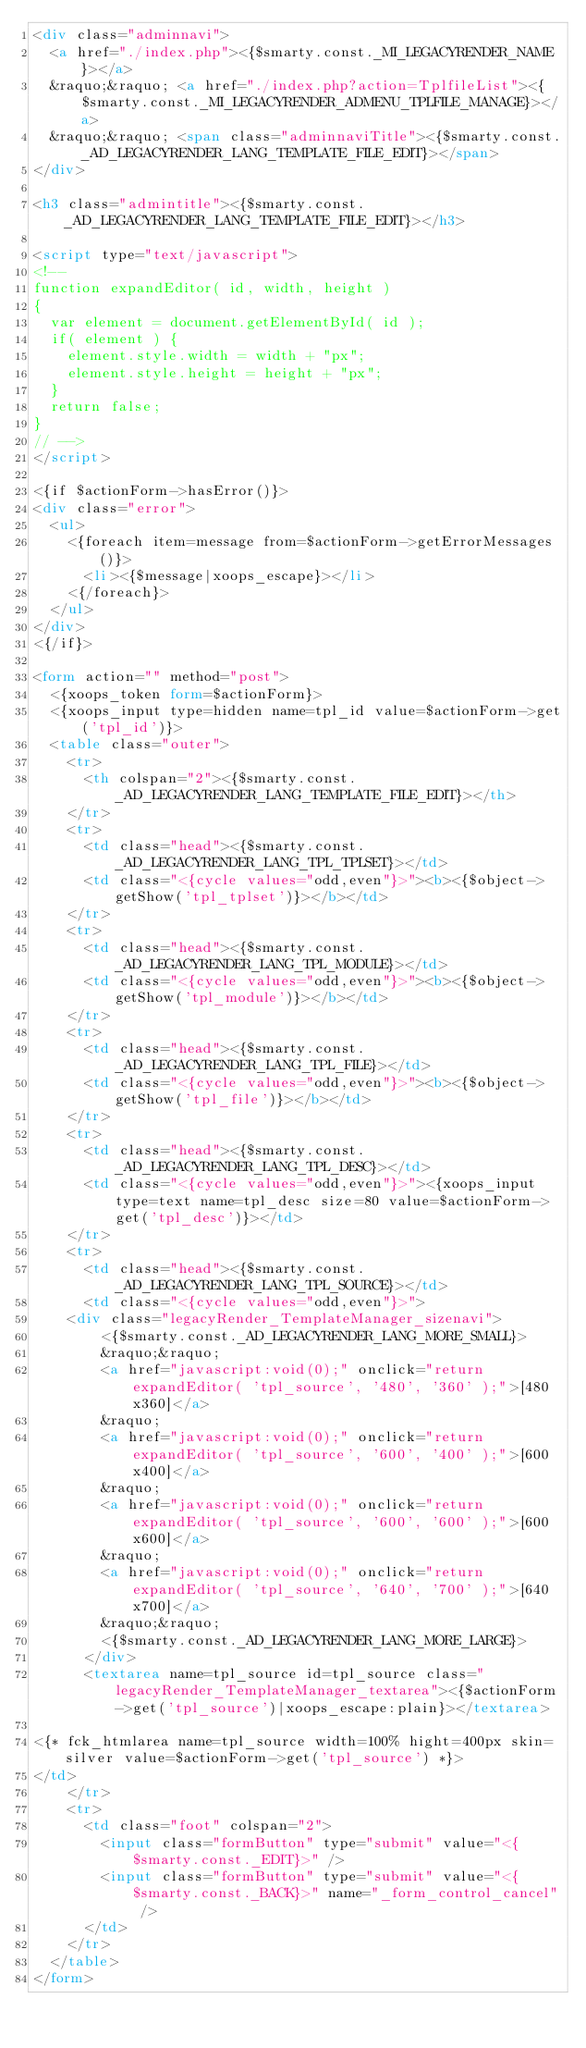Convert code to text. <code><loc_0><loc_0><loc_500><loc_500><_HTML_><div class="adminnavi">
  <a href="./index.php"><{$smarty.const._MI_LEGACYRENDER_NAME}></a>
  &raquo;&raquo; <a href="./index.php?action=TplfileList"><{$smarty.const._MI_LEGACYRENDER_ADMENU_TPLFILE_MANAGE}></a>
  &raquo;&raquo; <span class="adminnaviTitle"><{$smarty.const._AD_LEGACYRENDER_LANG_TEMPLATE_FILE_EDIT}></span>
</div>

<h3 class="admintitle"><{$smarty.const._AD_LEGACYRENDER_LANG_TEMPLATE_FILE_EDIT}></h3>

<script type="text/javascript">
<!--
function expandEditor( id, width, height )
{
  var element = document.getElementById( id );
  if( element ) {
    element.style.width = width + "px";
    element.style.height = height + "px";
  }
  return false;
}
// -->
</script>

<{if $actionForm->hasError()}>
<div class="error">
  <ul>
    <{foreach item=message from=$actionForm->getErrorMessages()}>
      <li><{$message|xoops_escape}></li>
    <{/foreach}>
  </ul>
</div>
<{/if}>

<form action="" method="post">
  <{xoops_token form=$actionForm}>
  <{xoops_input type=hidden name=tpl_id value=$actionForm->get('tpl_id')}>
  <table class="outer">
    <tr>
      <th colspan="2"><{$smarty.const._AD_LEGACYRENDER_LANG_TEMPLATE_FILE_EDIT}></th>
    </tr>
    <tr>
      <td class="head"><{$smarty.const._AD_LEGACYRENDER_LANG_TPL_TPLSET}></td>
      <td class="<{cycle values="odd,even"}>"><b><{$object->getShow('tpl_tplset')}></b></td>
    </tr>
    <tr>
      <td class="head"><{$smarty.const._AD_LEGACYRENDER_LANG_TPL_MODULE}></td>
      <td class="<{cycle values="odd,even"}>"><b><{$object->getShow('tpl_module')}></b></td>
    </tr>
    <tr>
      <td class="head"><{$smarty.const._AD_LEGACYRENDER_LANG_TPL_FILE}></td>
      <td class="<{cycle values="odd,even"}>"><b><{$object->getShow('tpl_file')}></b></td>
    </tr>
    <tr>
      <td class="head"><{$smarty.const._AD_LEGACYRENDER_LANG_TPL_DESC}></td>
      <td class="<{cycle values="odd,even"}>"><{xoops_input type=text name=tpl_desc size=80 value=$actionForm->get('tpl_desc')}></td>
    </tr>
    <tr>
      <td class="head"><{$smarty.const._AD_LEGACYRENDER_LANG_TPL_SOURCE}></td>
      <td class="<{cycle values="odd,even"}>">
    <div class="legacyRender_TemplateManager_sizenavi">
        <{$smarty.const._AD_LEGACYRENDER_LANG_MORE_SMALL}>
        &raquo;&raquo;
        <a href="javascript:void(0);" onclick="return expandEditor( 'tpl_source', '480', '360' );">[480x360]</a>
        &raquo;
        <a href="javascript:void(0);" onclick="return expandEditor( 'tpl_source', '600', '400' );">[600x400]</a>
        &raquo;
        <a href="javascript:void(0);" onclick="return expandEditor( 'tpl_source', '600', '600' );">[600x600]</a>
        &raquo;
        <a href="javascript:void(0);" onclick="return expandEditor( 'tpl_source', '640', '700' );">[640x700]</a>
        &raquo;&raquo;
        <{$smarty.const._AD_LEGACYRENDER_LANG_MORE_LARGE}>
      </div>
      <textarea name=tpl_source id=tpl_source class="legacyRender_TemplateManager_textarea"><{$actionForm->get('tpl_source')|xoops_escape:plain}></textarea>

<{* fck_htmlarea name=tpl_source width=100% hight=400px skin=silver value=$actionForm->get('tpl_source') *}>
</td>
    </tr>
    <tr>
      <td class="foot" colspan="2">
        <input class="formButton" type="submit" value="<{$smarty.const._EDIT}>" />
        <input class="formButton" type="submit" value="<{$smarty.const._BACK}>" name="_form_control_cancel" />
      </td>
    </tr>
  </table>
</form>
</code> 